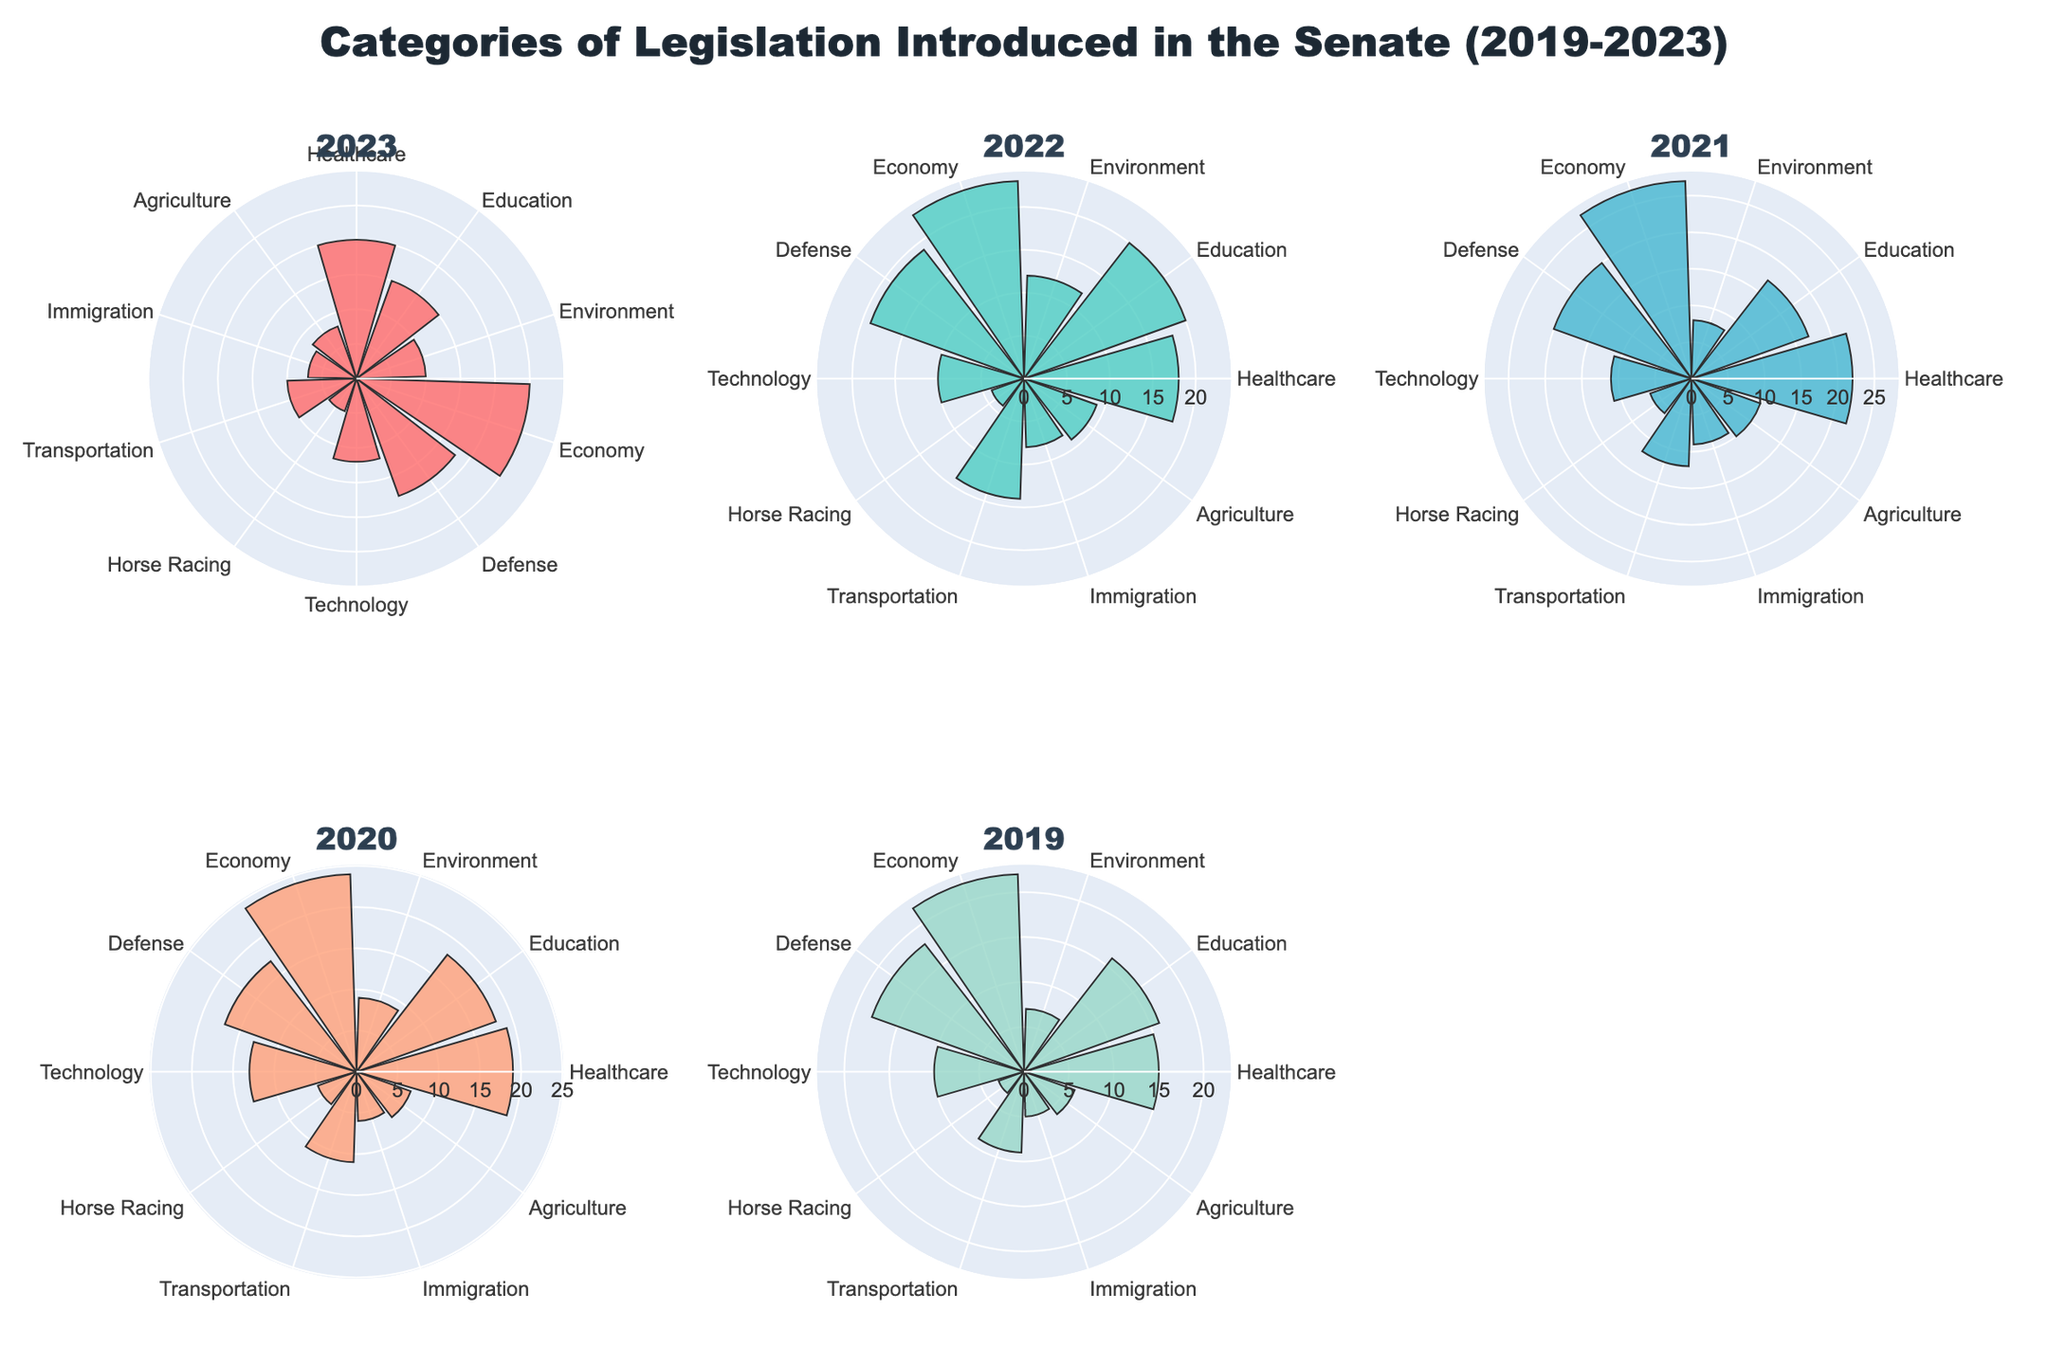What is the overall title of the figure? The title of the figure is displayed at the top.
Answer: "Categories of Legislation Introduced in the Senate (2019-2023)" Which year has the highest number of legislation in Horse Racing? By inspecting the Horse Racing category bar length in each year's subplot, the year with the highest value can be identified.
Answer: 2021 Compare the number of Healthcare and Economy legislations in 2020. Which is higher? Look at the lengths of the bars for Healthcare and Economy in the 2020 subplot to determine which is longer.
Answer: Economy What is the total number of legislations introduced for Technology from 2019 to 2023? Sum the values from the Technology category across all years: 12 + 10 + 11 + 13 + 10.
Answer: 56 How does the number of Defense legislations in 2019 compare to that in 2022? Compare the lengths of the Defense bar in the 2019 and 2022 subplots to see which is longer.
Answer: 2022 Which category had the least amount of legislation introduced in 2023? Identify the shortest bar in the 2023 subplot.
Answer: Horse Racing Among the given categories, which one shows a steady increase in legislations from 2019 to 2023? Check the trend lines for each category to see if there is a consistent increase year over year.
Answer: Education What is the average number of Economy legislations introduced over the five years? Sum the Economy values for each year and divide by 5: (25 + 23 + 27 + 24 + 22) / 5.
Answer: 24.2 Which category saw the largest increase in the number of legislations introduced from 2019 to 2020? Calculate the differences for all categories between 2019 and 2020 and find the largest positive change.
Answer: Transportation What is the difference between Education legislations introduced in 2022 and 2023? Subtract the number of Education legislations in 2022 from those in 2023: 15 - 20.
Answer: -5 